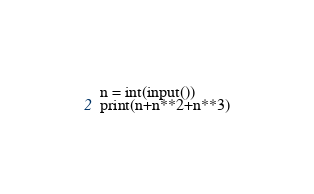<code> <loc_0><loc_0><loc_500><loc_500><_Python_>n = int(input())
print(n+n**2+n**3)</code> 